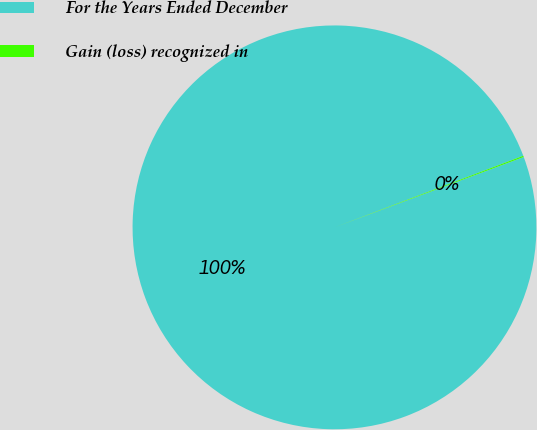<chart> <loc_0><loc_0><loc_500><loc_500><pie_chart><fcel>For the Years Ended December<fcel>Gain (loss) recognized in<nl><fcel>99.9%<fcel>0.1%<nl></chart> 